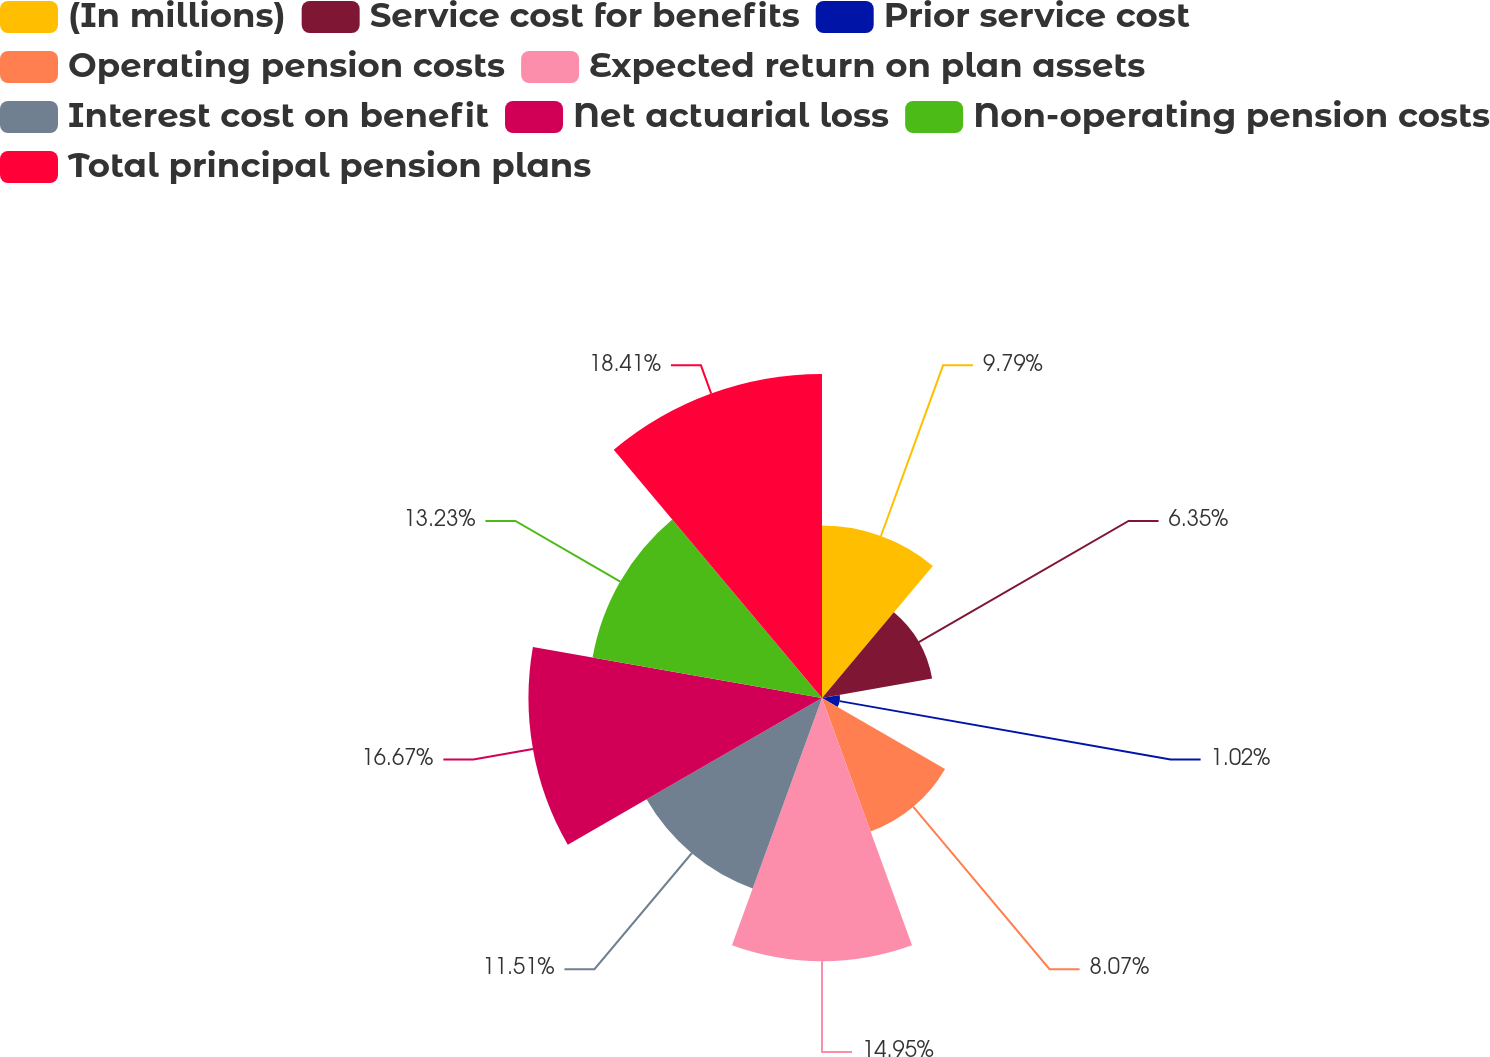Convert chart to OTSL. <chart><loc_0><loc_0><loc_500><loc_500><pie_chart><fcel>(In millions)<fcel>Service cost for benefits<fcel>Prior service cost<fcel>Operating pension costs<fcel>Expected return on plan assets<fcel>Interest cost on benefit<fcel>Net actuarial loss<fcel>Non-operating pension costs<fcel>Total principal pension plans<nl><fcel>9.79%<fcel>6.35%<fcel>1.02%<fcel>8.07%<fcel>14.95%<fcel>11.51%<fcel>16.67%<fcel>13.23%<fcel>18.4%<nl></chart> 